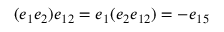<formula> <loc_0><loc_0><loc_500><loc_500>( e _ { 1 } e _ { 2 } ) e _ { 1 2 } = e _ { 1 } ( e _ { 2 } e _ { 1 2 } ) = - e _ { 1 5 }</formula> 